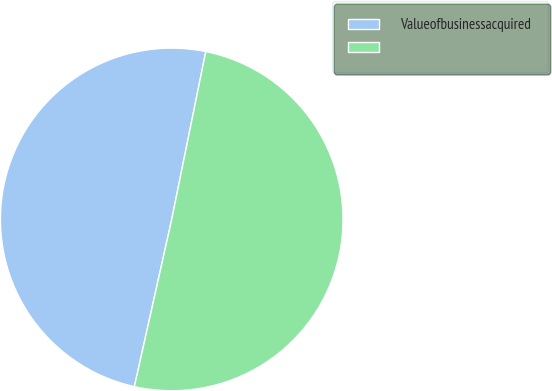Convert chart to OTSL. <chart><loc_0><loc_0><loc_500><loc_500><pie_chart><fcel>Valueofbusinessacquired<fcel>Unnamed: 1<nl><fcel>49.69%<fcel>50.31%<nl></chart> 